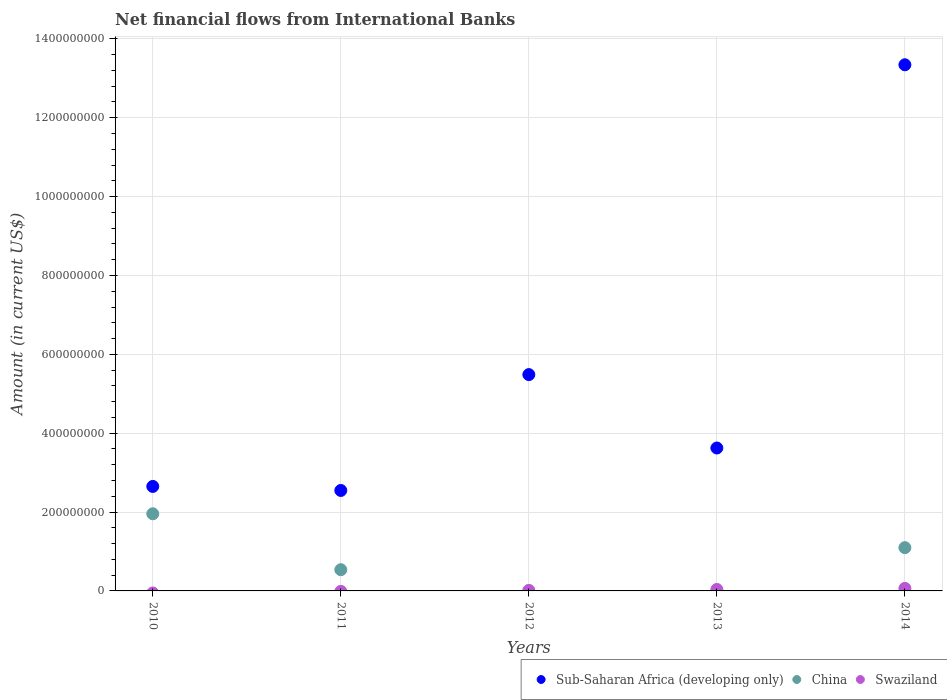How many different coloured dotlines are there?
Your answer should be very brief. 3. Is the number of dotlines equal to the number of legend labels?
Offer a terse response. No. What is the net financial aid flows in Swaziland in 2014?
Your answer should be very brief. 6.43e+06. Across all years, what is the maximum net financial aid flows in Sub-Saharan Africa (developing only)?
Keep it short and to the point. 1.33e+09. Across all years, what is the minimum net financial aid flows in China?
Your answer should be very brief. 0. In which year was the net financial aid flows in Swaziland maximum?
Provide a short and direct response. 2014. What is the total net financial aid flows in Swaziland in the graph?
Your answer should be compact. 1.14e+07. What is the difference between the net financial aid flows in China in 2011 and that in 2014?
Your response must be concise. -5.59e+07. What is the difference between the net financial aid flows in Sub-Saharan Africa (developing only) in 2014 and the net financial aid flows in Swaziland in 2012?
Your answer should be compact. 1.33e+09. What is the average net financial aid flows in Swaziland per year?
Offer a terse response. 2.27e+06. In the year 2013, what is the difference between the net financial aid flows in Sub-Saharan Africa (developing only) and net financial aid flows in Swaziland?
Provide a succinct answer. 3.59e+08. In how many years, is the net financial aid flows in China greater than 40000000 US$?
Keep it short and to the point. 3. What is the ratio of the net financial aid flows in Sub-Saharan Africa (developing only) in 2011 to that in 2014?
Make the answer very short. 0.19. Is the difference between the net financial aid flows in Sub-Saharan Africa (developing only) in 2013 and 2014 greater than the difference between the net financial aid flows in Swaziland in 2013 and 2014?
Offer a terse response. No. What is the difference between the highest and the second highest net financial aid flows in Swaziland?
Keep it short and to the point. 2.77e+06. What is the difference between the highest and the lowest net financial aid flows in China?
Keep it short and to the point. 1.96e+08. Does the net financial aid flows in Swaziland monotonically increase over the years?
Your answer should be compact. Yes. How many dotlines are there?
Provide a short and direct response. 3. How many years are there in the graph?
Ensure brevity in your answer.  5. What is the difference between two consecutive major ticks on the Y-axis?
Offer a very short reply. 2.00e+08. Are the values on the major ticks of Y-axis written in scientific E-notation?
Keep it short and to the point. No. What is the title of the graph?
Your response must be concise. Net financial flows from International Banks. Does "Congo (Republic)" appear as one of the legend labels in the graph?
Your answer should be very brief. No. What is the label or title of the X-axis?
Give a very brief answer. Years. What is the label or title of the Y-axis?
Provide a short and direct response. Amount (in current US$). What is the Amount (in current US$) of Sub-Saharan Africa (developing only) in 2010?
Your response must be concise. 2.65e+08. What is the Amount (in current US$) in China in 2010?
Provide a succinct answer. 1.96e+08. What is the Amount (in current US$) in Sub-Saharan Africa (developing only) in 2011?
Give a very brief answer. 2.55e+08. What is the Amount (in current US$) of China in 2011?
Your response must be concise. 5.38e+07. What is the Amount (in current US$) of Swaziland in 2011?
Your answer should be very brief. 0. What is the Amount (in current US$) of Sub-Saharan Africa (developing only) in 2012?
Your response must be concise. 5.49e+08. What is the Amount (in current US$) in Swaziland in 2012?
Offer a terse response. 1.28e+06. What is the Amount (in current US$) in Sub-Saharan Africa (developing only) in 2013?
Your response must be concise. 3.62e+08. What is the Amount (in current US$) in Swaziland in 2013?
Your response must be concise. 3.66e+06. What is the Amount (in current US$) in Sub-Saharan Africa (developing only) in 2014?
Make the answer very short. 1.33e+09. What is the Amount (in current US$) in China in 2014?
Provide a short and direct response. 1.10e+08. What is the Amount (in current US$) of Swaziland in 2014?
Offer a very short reply. 6.43e+06. Across all years, what is the maximum Amount (in current US$) of Sub-Saharan Africa (developing only)?
Provide a succinct answer. 1.33e+09. Across all years, what is the maximum Amount (in current US$) in China?
Make the answer very short. 1.96e+08. Across all years, what is the maximum Amount (in current US$) of Swaziland?
Offer a terse response. 6.43e+06. Across all years, what is the minimum Amount (in current US$) in Sub-Saharan Africa (developing only)?
Your answer should be compact. 2.55e+08. What is the total Amount (in current US$) in Sub-Saharan Africa (developing only) in the graph?
Provide a succinct answer. 2.77e+09. What is the total Amount (in current US$) of China in the graph?
Offer a very short reply. 3.59e+08. What is the total Amount (in current US$) of Swaziland in the graph?
Ensure brevity in your answer.  1.14e+07. What is the difference between the Amount (in current US$) of Sub-Saharan Africa (developing only) in 2010 and that in 2011?
Offer a very short reply. 1.02e+07. What is the difference between the Amount (in current US$) in China in 2010 and that in 2011?
Your response must be concise. 1.42e+08. What is the difference between the Amount (in current US$) of Sub-Saharan Africa (developing only) in 2010 and that in 2012?
Make the answer very short. -2.84e+08. What is the difference between the Amount (in current US$) in Sub-Saharan Africa (developing only) in 2010 and that in 2013?
Make the answer very short. -9.74e+07. What is the difference between the Amount (in current US$) of Sub-Saharan Africa (developing only) in 2010 and that in 2014?
Provide a short and direct response. -1.07e+09. What is the difference between the Amount (in current US$) of China in 2010 and that in 2014?
Offer a terse response. 8.59e+07. What is the difference between the Amount (in current US$) in Sub-Saharan Africa (developing only) in 2011 and that in 2012?
Give a very brief answer. -2.94e+08. What is the difference between the Amount (in current US$) in Sub-Saharan Africa (developing only) in 2011 and that in 2013?
Offer a terse response. -1.08e+08. What is the difference between the Amount (in current US$) of Sub-Saharan Africa (developing only) in 2011 and that in 2014?
Keep it short and to the point. -1.08e+09. What is the difference between the Amount (in current US$) in China in 2011 and that in 2014?
Provide a short and direct response. -5.59e+07. What is the difference between the Amount (in current US$) of Sub-Saharan Africa (developing only) in 2012 and that in 2013?
Your response must be concise. 1.86e+08. What is the difference between the Amount (in current US$) in Swaziland in 2012 and that in 2013?
Offer a very short reply. -2.38e+06. What is the difference between the Amount (in current US$) in Sub-Saharan Africa (developing only) in 2012 and that in 2014?
Ensure brevity in your answer.  -7.86e+08. What is the difference between the Amount (in current US$) of Swaziland in 2012 and that in 2014?
Keep it short and to the point. -5.16e+06. What is the difference between the Amount (in current US$) of Sub-Saharan Africa (developing only) in 2013 and that in 2014?
Provide a succinct answer. -9.72e+08. What is the difference between the Amount (in current US$) in Swaziland in 2013 and that in 2014?
Provide a short and direct response. -2.77e+06. What is the difference between the Amount (in current US$) of Sub-Saharan Africa (developing only) in 2010 and the Amount (in current US$) of China in 2011?
Provide a succinct answer. 2.11e+08. What is the difference between the Amount (in current US$) of Sub-Saharan Africa (developing only) in 2010 and the Amount (in current US$) of Swaziland in 2012?
Keep it short and to the point. 2.64e+08. What is the difference between the Amount (in current US$) in China in 2010 and the Amount (in current US$) in Swaziland in 2012?
Your response must be concise. 1.94e+08. What is the difference between the Amount (in current US$) of Sub-Saharan Africa (developing only) in 2010 and the Amount (in current US$) of Swaziland in 2013?
Provide a succinct answer. 2.61e+08. What is the difference between the Amount (in current US$) of China in 2010 and the Amount (in current US$) of Swaziland in 2013?
Provide a succinct answer. 1.92e+08. What is the difference between the Amount (in current US$) in Sub-Saharan Africa (developing only) in 2010 and the Amount (in current US$) in China in 2014?
Offer a very short reply. 1.55e+08. What is the difference between the Amount (in current US$) in Sub-Saharan Africa (developing only) in 2010 and the Amount (in current US$) in Swaziland in 2014?
Offer a very short reply. 2.59e+08. What is the difference between the Amount (in current US$) in China in 2010 and the Amount (in current US$) in Swaziland in 2014?
Give a very brief answer. 1.89e+08. What is the difference between the Amount (in current US$) of Sub-Saharan Africa (developing only) in 2011 and the Amount (in current US$) of Swaziland in 2012?
Keep it short and to the point. 2.53e+08. What is the difference between the Amount (in current US$) of China in 2011 and the Amount (in current US$) of Swaziland in 2012?
Your answer should be very brief. 5.25e+07. What is the difference between the Amount (in current US$) in Sub-Saharan Africa (developing only) in 2011 and the Amount (in current US$) in Swaziland in 2013?
Your response must be concise. 2.51e+08. What is the difference between the Amount (in current US$) in China in 2011 and the Amount (in current US$) in Swaziland in 2013?
Offer a very short reply. 5.01e+07. What is the difference between the Amount (in current US$) of Sub-Saharan Africa (developing only) in 2011 and the Amount (in current US$) of China in 2014?
Your answer should be very brief. 1.45e+08. What is the difference between the Amount (in current US$) in Sub-Saharan Africa (developing only) in 2011 and the Amount (in current US$) in Swaziland in 2014?
Your answer should be compact. 2.48e+08. What is the difference between the Amount (in current US$) in China in 2011 and the Amount (in current US$) in Swaziland in 2014?
Offer a terse response. 4.74e+07. What is the difference between the Amount (in current US$) in Sub-Saharan Africa (developing only) in 2012 and the Amount (in current US$) in Swaziland in 2013?
Keep it short and to the point. 5.45e+08. What is the difference between the Amount (in current US$) of Sub-Saharan Africa (developing only) in 2012 and the Amount (in current US$) of China in 2014?
Keep it short and to the point. 4.39e+08. What is the difference between the Amount (in current US$) of Sub-Saharan Africa (developing only) in 2012 and the Amount (in current US$) of Swaziland in 2014?
Give a very brief answer. 5.42e+08. What is the difference between the Amount (in current US$) in Sub-Saharan Africa (developing only) in 2013 and the Amount (in current US$) in China in 2014?
Offer a very short reply. 2.53e+08. What is the difference between the Amount (in current US$) of Sub-Saharan Africa (developing only) in 2013 and the Amount (in current US$) of Swaziland in 2014?
Your answer should be compact. 3.56e+08. What is the average Amount (in current US$) in Sub-Saharan Africa (developing only) per year?
Provide a short and direct response. 5.53e+08. What is the average Amount (in current US$) of China per year?
Provide a short and direct response. 7.18e+07. What is the average Amount (in current US$) in Swaziland per year?
Your response must be concise. 2.27e+06. In the year 2010, what is the difference between the Amount (in current US$) in Sub-Saharan Africa (developing only) and Amount (in current US$) in China?
Give a very brief answer. 6.94e+07. In the year 2011, what is the difference between the Amount (in current US$) in Sub-Saharan Africa (developing only) and Amount (in current US$) in China?
Ensure brevity in your answer.  2.01e+08. In the year 2012, what is the difference between the Amount (in current US$) of Sub-Saharan Africa (developing only) and Amount (in current US$) of Swaziland?
Offer a terse response. 5.47e+08. In the year 2013, what is the difference between the Amount (in current US$) in Sub-Saharan Africa (developing only) and Amount (in current US$) in Swaziland?
Your response must be concise. 3.59e+08. In the year 2014, what is the difference between the Amount (in current US$) in Sub-Saharan Africa (developing only) and Amount (in current US$) in China?
Give a very brief answer. 1.22e+09. In the year 2014, what is the difference between the Amount (in current US$) in Sub-Saharan Africa (developing only) and Amount (in current US$) in Swaziland?
Your response must be concise. 1.33e+09. In the year 2014, what is the difference between the Amount (in current US$) in China and Amount (in current US$) in Swaziland?
Make the answer very short. 1.03e+08. What is the ratio of the Amount (in current US$) in Sub-Saharan Africa (developing only) in 2010 to that in 2011?
Offer a very short reply. 1.04. What is the ratio of the Amount (in current US$) of China in 2010 to that in 2011?
Offer a very short reply. 3.64. What is the ratio of the Amount (in current US$) of Sub-Saharan Africa (developing only) in 2010 to that in 2012?
Offer a terse response. 0.48. What is the ratio of the Amount (in current US$) of Sub-Saharan Africa (developing only) in 2010 to that in 2013?
Offer a very short reply. 0.73. What is the ratio of the Amount (in current US$) in Sub-Saharan Africa (developing only) in 2010 to that in 2014?
Offer a terse response. 0.2. What is the ratio of the Amount (in current US$) in China in 2010 to that in 2014?
Your response must be concise. 1.78. What is the ratio of the Amount (in current US$) in Sub-Saharan Africa (developing only) in 2011 to that in 2012?
Ensure brevity in your answer.  0.46. What is the ratio of the Amount (in current US$) of Sub-Saharan Africa (developing only) in 2011 to that in 2013?
Give a very brief answer. 0.7. What is the ratio of the Amount (in current US$) in Sub-Saharan Africa (developing only) in 2011 to that in 2014?
Offer a terse response. 0.19. What is the ratio of the Amount (in current US$) of China in 2011 to that in 2014?
Your answer should be very brief. 0.49. What is the ratio of the Amount (in current US$) in Sub-Saharan Africa (developing only) in 2012 to that in 2013?
Ensure brevity in your answer.  1.51. What is the ratio of the Amount (in current US$) in Swaziland in 2012 to that in 2013?
Your answer should be compact. 0.35. What is the ratio of the Amount (in current US$) in Sub-Saharan Africa (developing only) in 2012 to that in 2014?
Offer a very short reply. 0.41. What is the ratio of the Amount (in current US$) of Swaziland in 2012 to that in 2014?
Offer a terse response. 0.2. What is the ratio of the Amount (in current US$) in Sub-Saharan Africa (developing only) in 2013 to that in 2014?
Keep it short and to the point. 0.27. What is the ratio of the Amount (in current US$) of Swaziland in 2013 to that in 2014?
Provide a succinct answer. 0.57. What is the difference between the highest and the second highest Amount (in current US$) of Sub-Saharan Africa (developing only)?
Ensure brevity in your answer.  7.86e+08. What is the difference between the highest and the second highest Amount (in current US$) of China?
Offer a very short reply. 8.59e+07. What is the difference between the highest and the second highest Amount (in current US$) in Swaziland?
Make the answer very short. 2.77e+06. What is the difference between the highest and the lowest Amount (in current US$) of Sub-Saharan Africa (developing only)?
Offer a terse response. 1.08e+09. What is the difference between the highest and the lowest Amount (in current US$) in China?
Provide a succinct answer. 1.96e+08. What is the difference between the highest and the lowest Amount (in current US$) of Swaziland?
Your answer should be compact. 6.43e+06. 